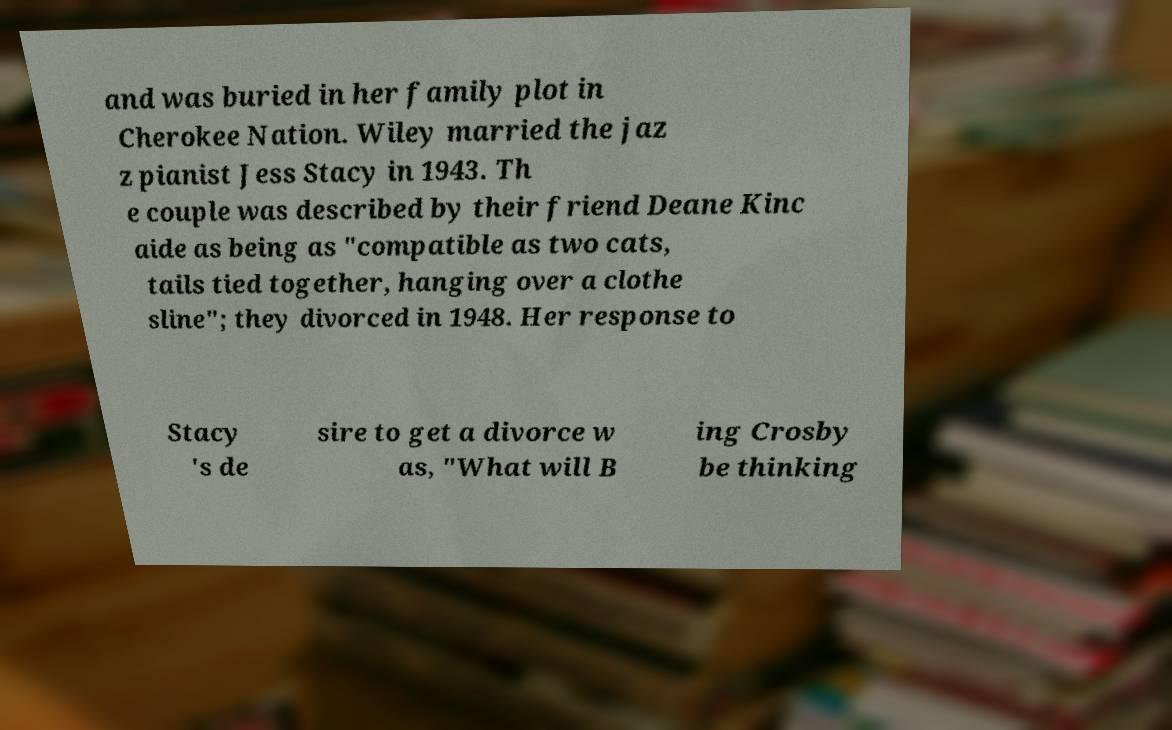Please read and relay the text visible in this image. What does it say? and was buried in her family plot in Cherokee Nation. Wiley married the jaz z pianist Jess Stacy in 1943. Th e couple was described by their friend Deane Kinc aide as being as "compatible as two cats, tails tied together, hanging over a clothe sline"; they divorced in 1948. Her response to Stacy 's de sire to get a divorce w as, "What will B ing Crosby be thinking 